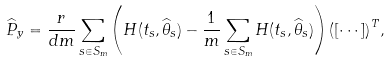<formula> <loc_0><loc_0><loc_500><loc_500>\widehat { P } _ { y } = \frac { r } { d m } \sum _ { s \in S _ { m } } { \left ( H ( t _ { s } , \widehat { \theta } _ { s } ) - \frac { 1 } { m } \sum _ { s \in S _ { m } } { H ( t _ { s } , \widehat { \theta } _ { s } } ) \right ) \left ( [ \cdots ] \right ) ^ { T } } ,</formula> 